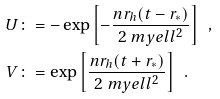Convert formula to latex. <formula><loc_0><loc_0><loc_500><loc_500>U & \colon = - \exp \left [ - \frac { n r _ { h } ( t - r _ { * } ) } { 2 \ m y e l l ^ { 2 } } \right ] \ \ , \\ V & \colon = \exp \left [ \frac { n r _ { h } ( t + r _ { * } ) } { 2 \ m y e l l ^ { 2 } } \right ] \ \ .</formula> 